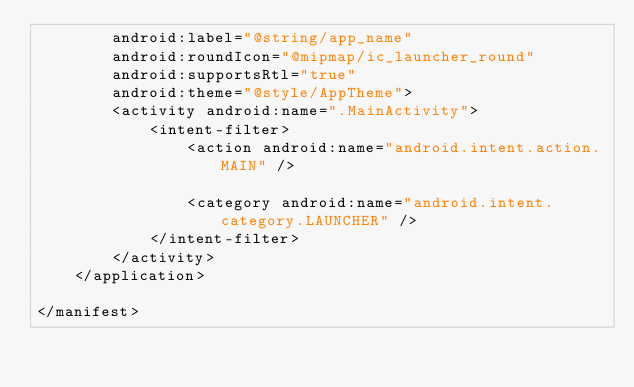<code> <loc_0><loc_0><loc_500><loc_500><_XML_>        android:label="@string/app_name"
        android:roundIcon="@mipmap/ic_launcher_round"
        android:supportsRtl="true"
        android:theme="@style/AppTheme">
        <activity android:name=".MainActivity">
            <intent-filter>
                <action android:name="android.intent.action.MAIN" />

                <category android:name="android.intent.category.LAUNCHER" />
            </intent-filter>
        </activity>
    </application>

</manifest></code> 